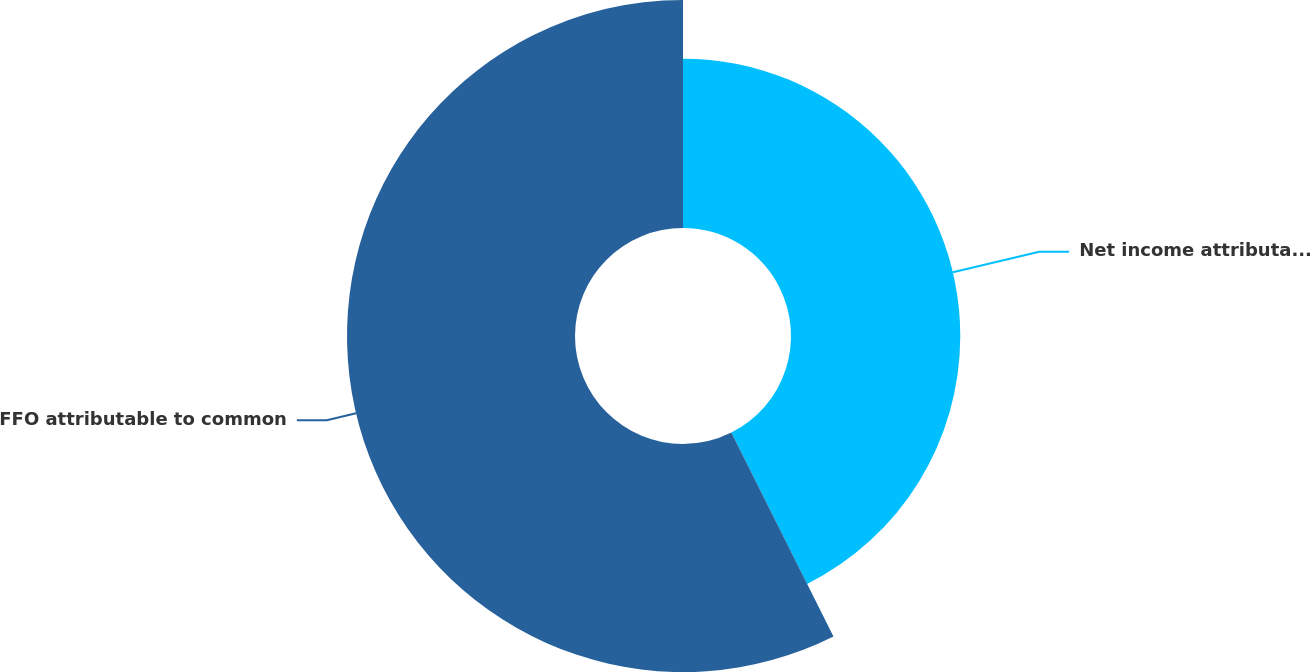Convert chart to OTSL. <chart><loc_0><loc_0><loc_500><loc_500><pie_chart><fcel>Net income attributable to<fcel>FFO attributable to common<nl><fcel>42.61%<fcel>57.39%<nl></chart> 